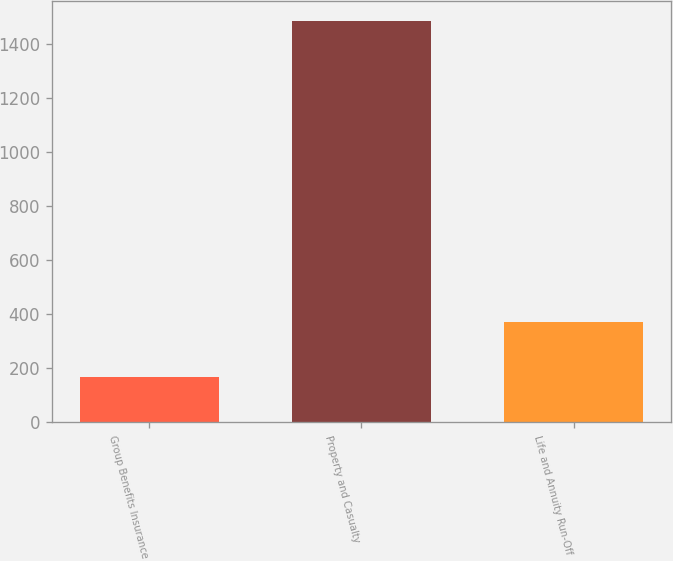Convert chart. <chart><loc_0><loc_0><loc_500><loc_500><bar_chart><fcel>Group Benefits Insurance<fcel>Property and Casualty<fcel>Life and Annuity Run-Off<nl><fcel>168<fcel>1486<fcel>371<nl></chart> 